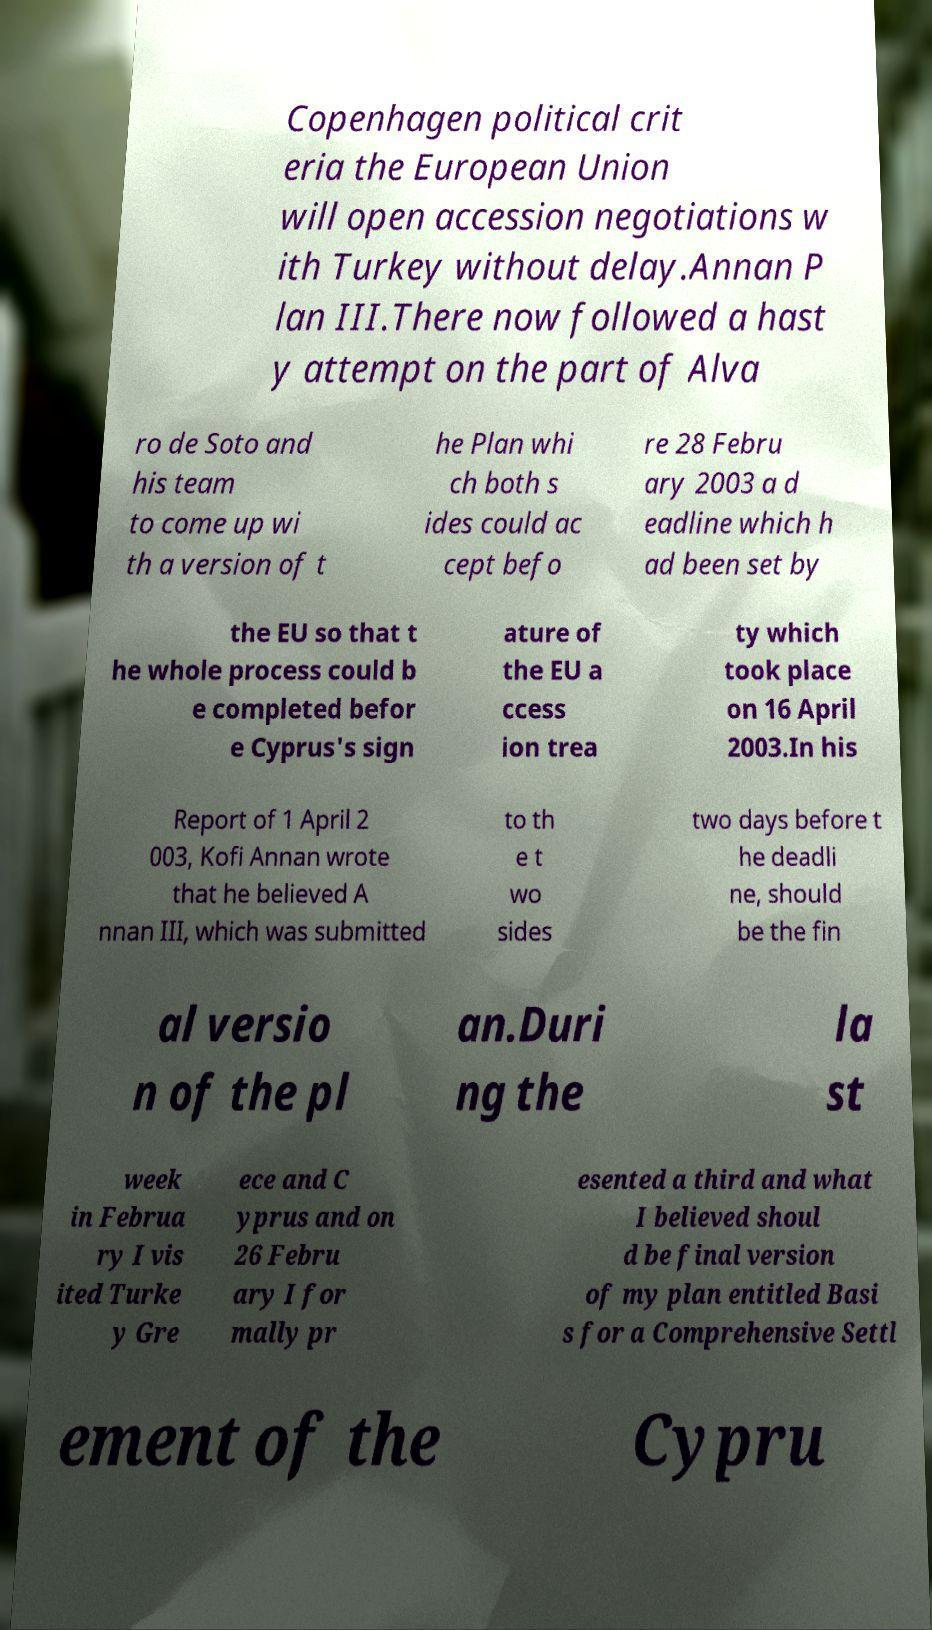I need the written content from this picture converted into text. Can you do that? Copenhagen political crit eria the European Union will open accession negotiations w ith Turkey without delay.Annan P lan III.There now followed a hast y attempt on the part of Alva ro de Soto and his team to come up wi th a version of t he Plan whi ch both s ides could ac cept befo re 28 Febru ary 2003 a d eadline which h ad been set by the EU so that t he whole process could b e completed befor e Cyprus's sign ature of the EU a ccess ion trea ty which took place on 16 April 2003.In his Report of 1 April 2 003, Kofi Annan wrote that he believed A nnan III, which was submitted to th e t wo sides two days before t he deadli ne, should be the fin al versio n of the pl an.Duri ng the la st week in Februa ry I vis ited Turke y Gre ece and C yprus and on 26 Febru ary I for mally pr esented a third and what I believed shoul d be final version of my plan entitled Basi s for a Comprehensive Settl ement of the Cypru 